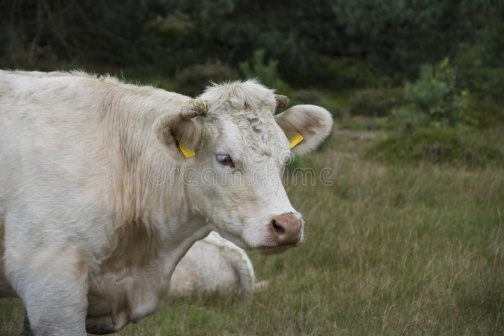What time of day does this scene represent based on the lighting and shadows? The soft, diffused light and mild shadows around the cow suggest either early morning or late afternoon. This lighting creates a calm and serene atmosphere, typical of these times when the sun is low in the sky. These periods are often chosen by photographers to capture the natural world due to the warm and flattering light conditions. 